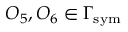Convert formula to latex. <formula><loc_0><loc_0><loc_500><loc_500>O _ { 5 } , O _ { 6 } \in \Gamma _ { s y m }</formula> 